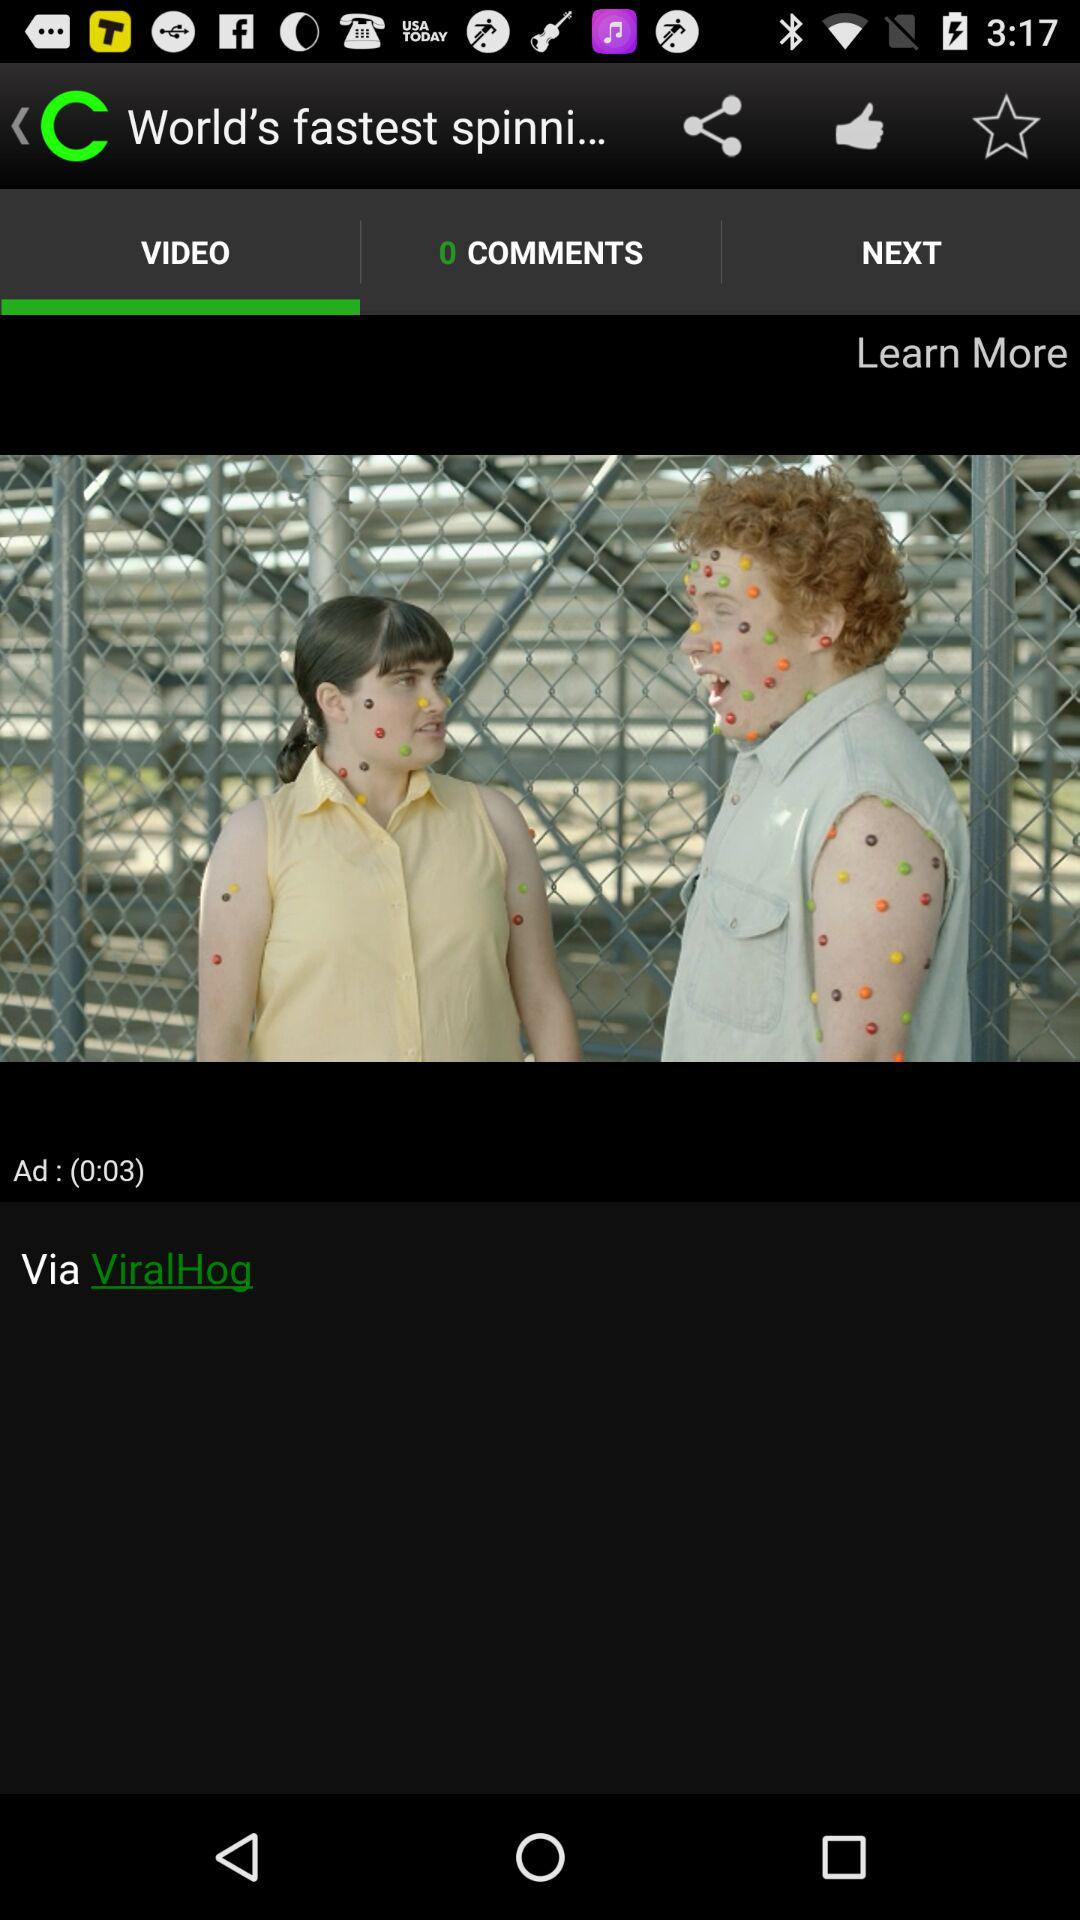How many views does the video have?
When the provided information is insufficient, respond with <no answer>. <no answer> 